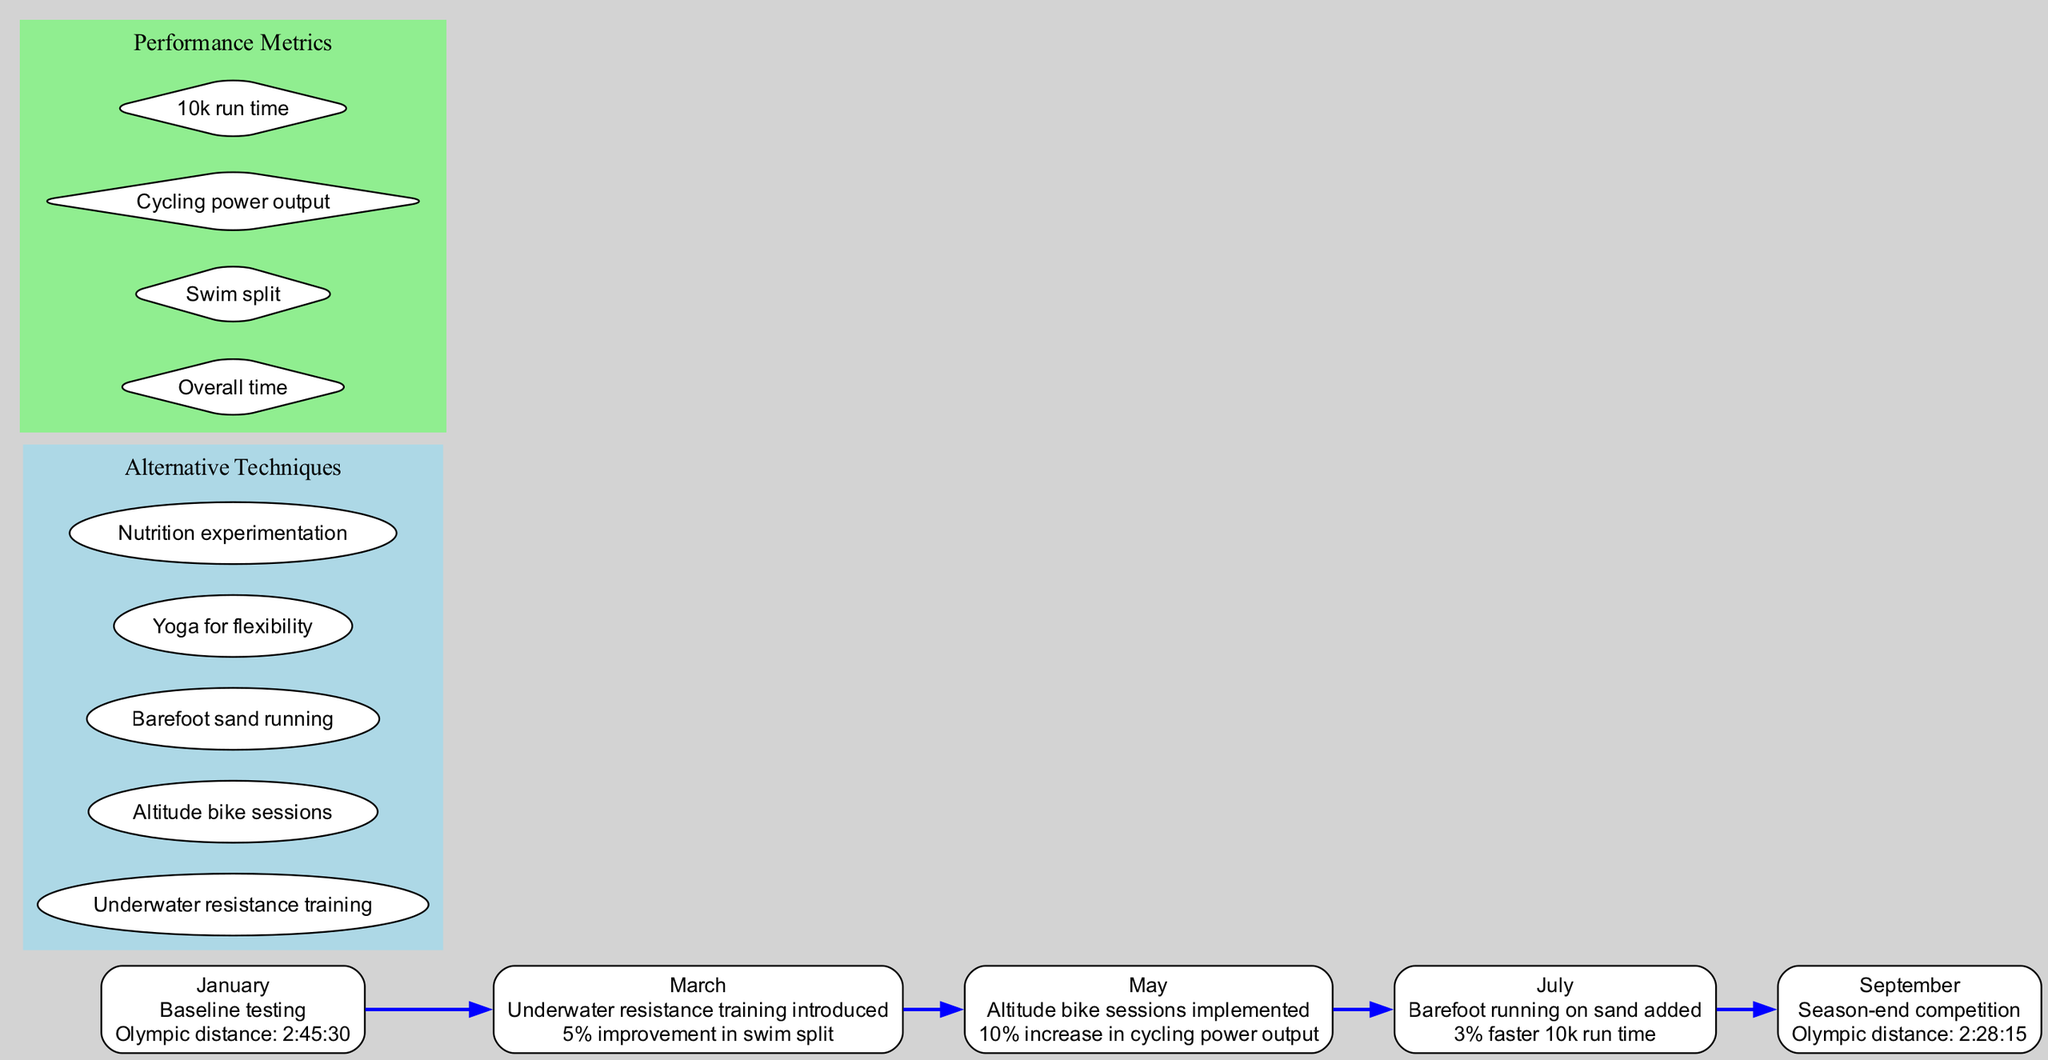What was the performance time at the season-end competition? The diagram includes a timeline event for the season-end competition in September, which states the performance as 2:28:15.
Answer: 2:28:15 How much improvement was made in swim split after introducing underwater resistance training? The timeline event from March indicates a 5% improvement in swim split after introducing underwater resistance training.
Answer: 5% improvement Which alternative training technique was implemented in May? Looking at the timeline events, May has an entry that mentions the implementation of altitude bike sessions.
Answer: Altitude bike sessions What was the increase in cycling power output after implementing altitude bike sessions? The event in May indicates that there was a 10% increase in cycling power output after the altitude bike sessions were implemented.
Answer: 10% increase What were the two training techniques introduced before the season-end competition? Looking at the timeline, the two techniques introduced before September were barefoot running on sand in July and altitude bike sessions in May.
Answer: Barefoot running on sand, Altitude bike sessions How many performance metrics are listed in the diagram? The performance metrics section in the diagram contains four distinct entries: overall time, swim split, cycling power output, and 10k run time.
Answer: 4 Which month did the baseline testing occur? The diagram states that baseline testing occurred in January as the first event in the timeline.
Answer: January What event led to a 3% faster 10k run time? The entry in July indicates that the addition of barefoot running on sand led to a 3% faster 10k run time.
Answer: Barefoot running on sand 